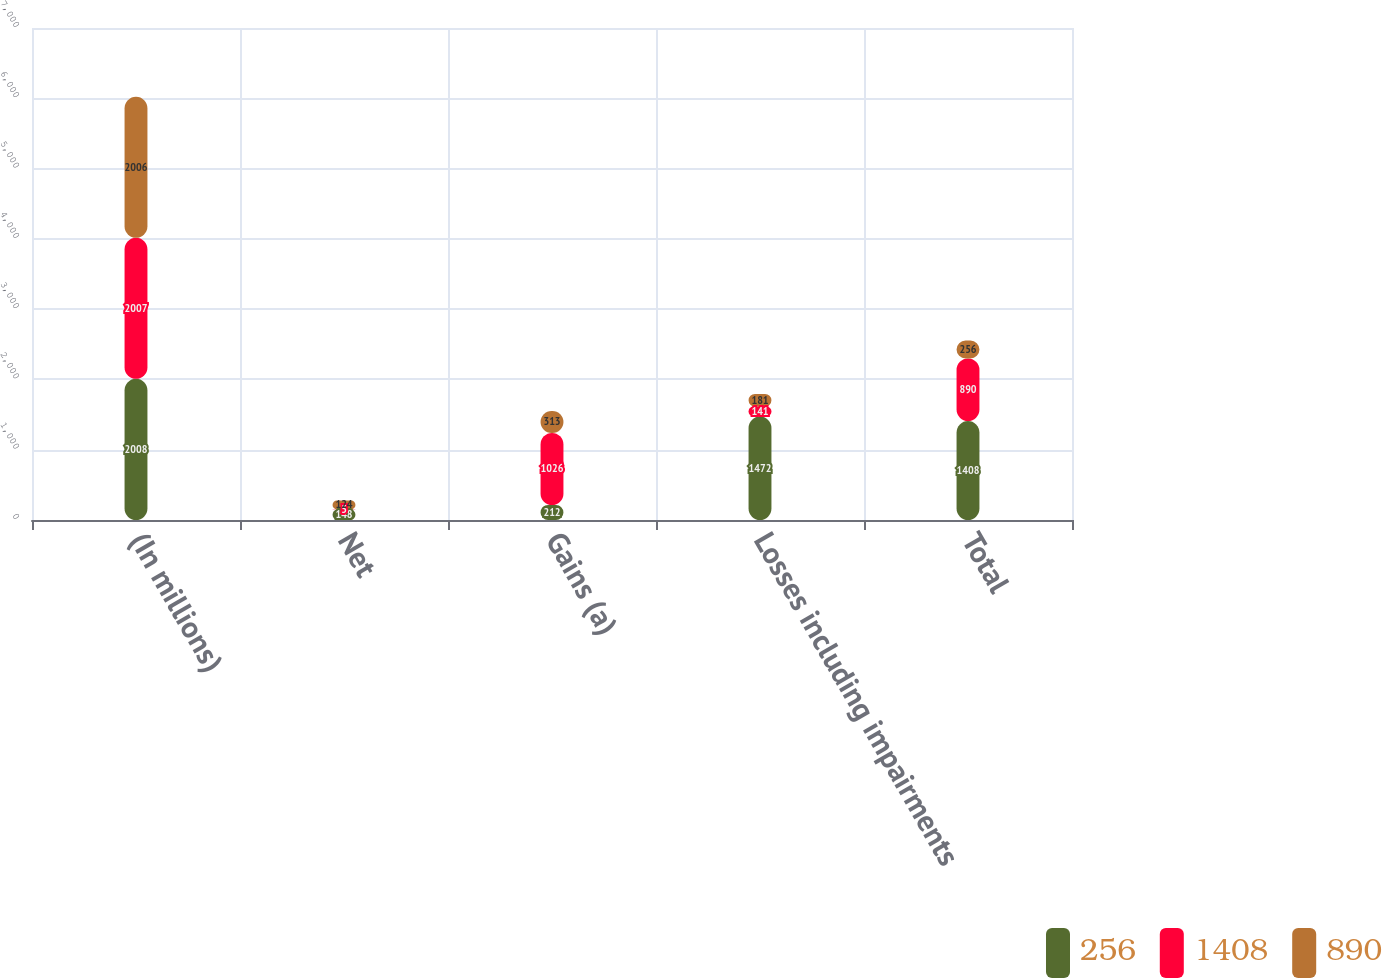Convert chart to OTSL. <chart><loc_0><loc_0><loc_500><loc_500><stacked_bar_chart><ecel><fcel>(In millions)<fcel>Net<fcel>Gains (a)<fcel>Losses including impairments<fcel>Total<nl><fcel>256<fcel>2008<fcel>148<fcel>212<fcel>1472<fcel>1408<nl><fcel>1408<fcel>2007<fcel>5<fcel>1026<fcel>141<fcel>890<nl><fcel>890<fcel>2006<fcel>124<fcel>313<fcel>181<fcel>256<nl></chart> 